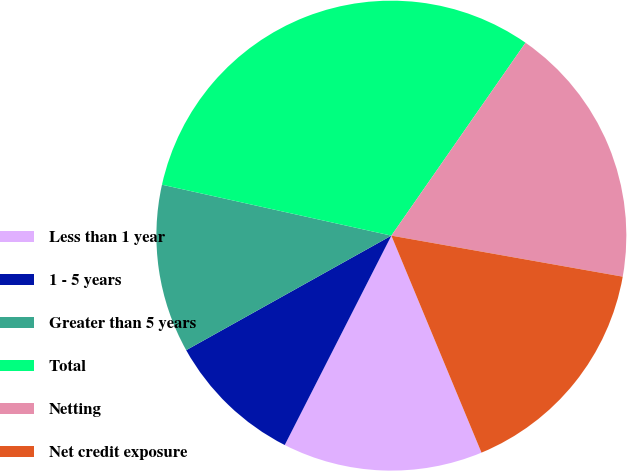Convert chart to OTSL. <chart><loc_0><loc_0><loc_500><loc_500><pie_chart><fcel>Less than 1 year<fcel>1 - 5 years<fcel>Greater than 5 years<fcel>Total<fcel>Netting<fcel>Net credit exposure<nl><fcel>13.76%<fcel>9.4%<fcel>11.58%<fcel>31.19%<fcel>18.12%<fcel>15.94%<nl></chart> 